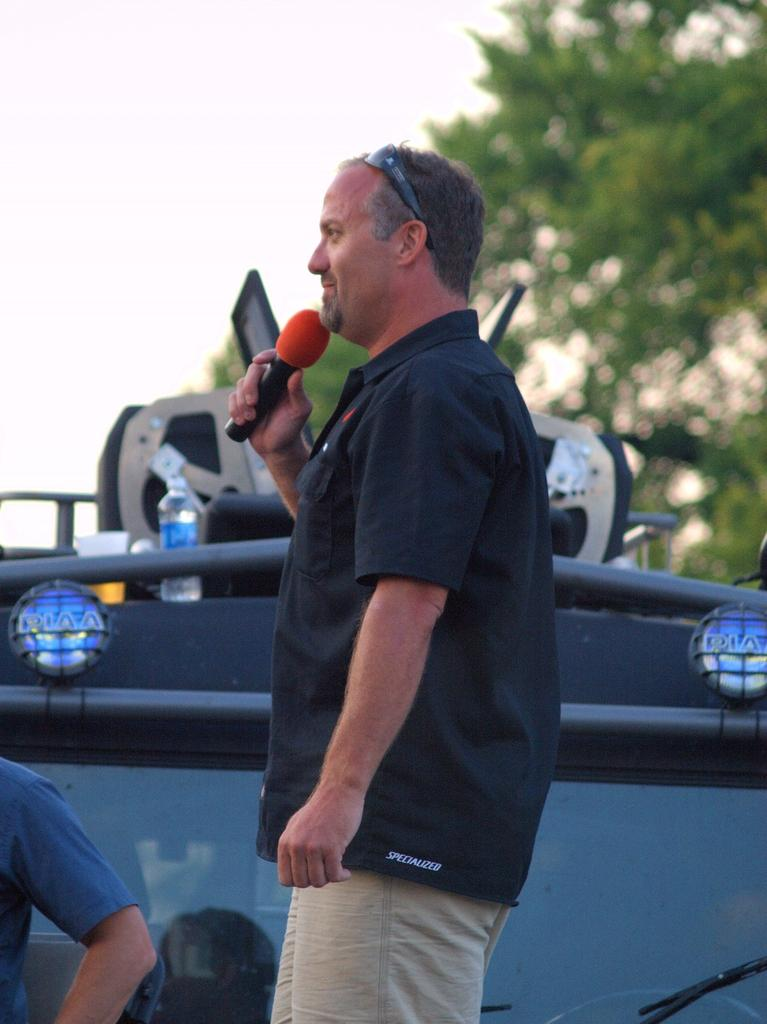Who is present in the image? There is a man in the image. What is the man holding in the image? The man is holding a mic. What can be seen in the background of the image? There is a bottle, equipment, and trees in the background of the image. What type of boot is the man wearing in the image? There is no mention of boots or footwear in the image, so it cannot be determined what type of boot the man might be wearing. 